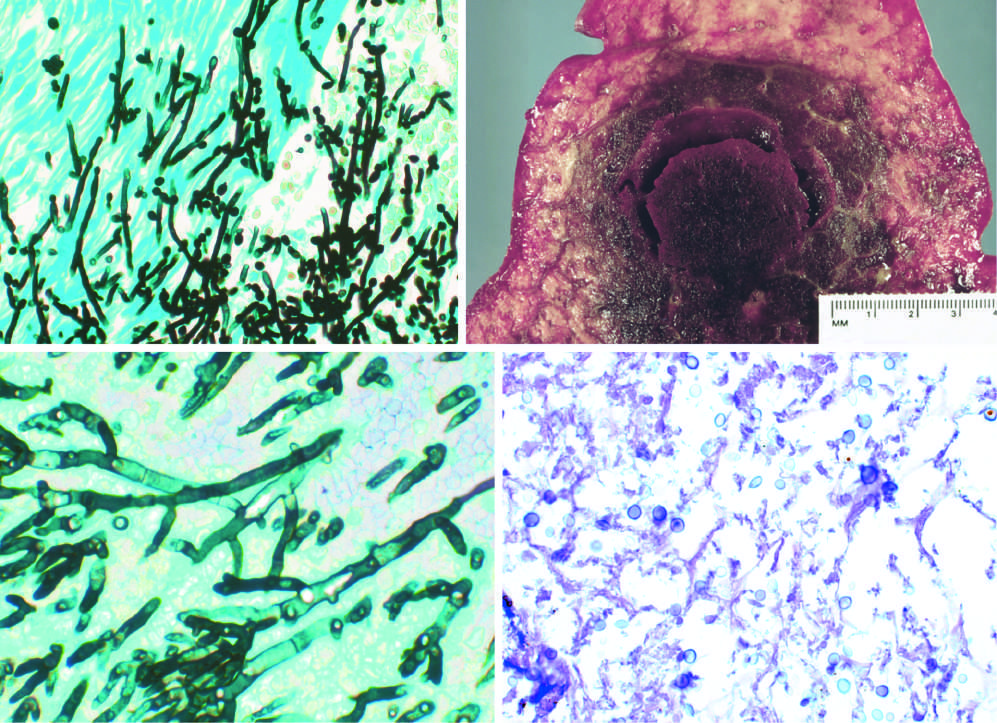what shows septate hyphae with acute-angle branching, consistent with aspergillus?
Answer the question using a single word or phrase. Gomori methenamine-silver (gms) stain 